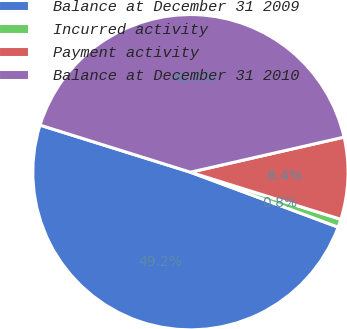Convert chart. <chart><loc_0><loc_0><loc_500><loc_500><pie_chart><fcel>Balance at December 31 2009<fcel>Incurred activity<fcel>Payment activity<fcel>Balance at December 31 2010<nl><fcel>49.16%<fcel>0.84%<fcel>8.4%<fcel>41.6%<nl></chart> 